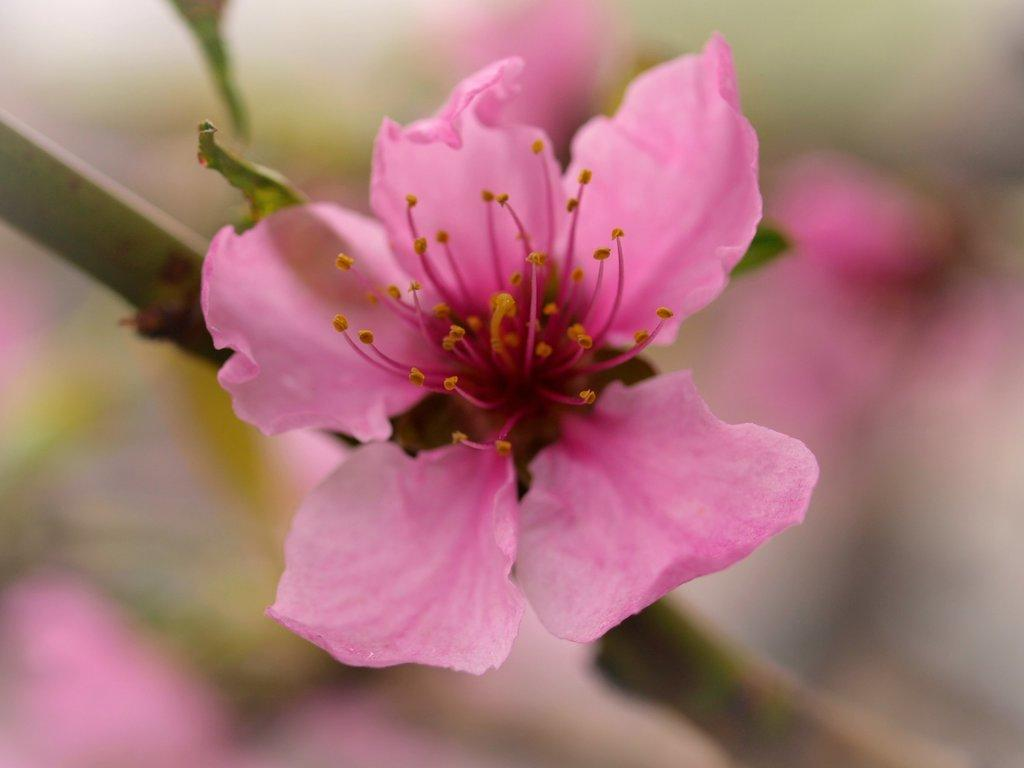What is the main subject of the image? There is a flower in the image. What color is the flower? The flower is pink in color. Can you describe any other part of the flower besides the petals? The stem of the flower is visible. How would you describe the background of the image? The background of the image appears blurry. How many sticks are visible in the image? There are no sticks present in the image. What type of sun can be seen in the image? There is no sun present in the image. 